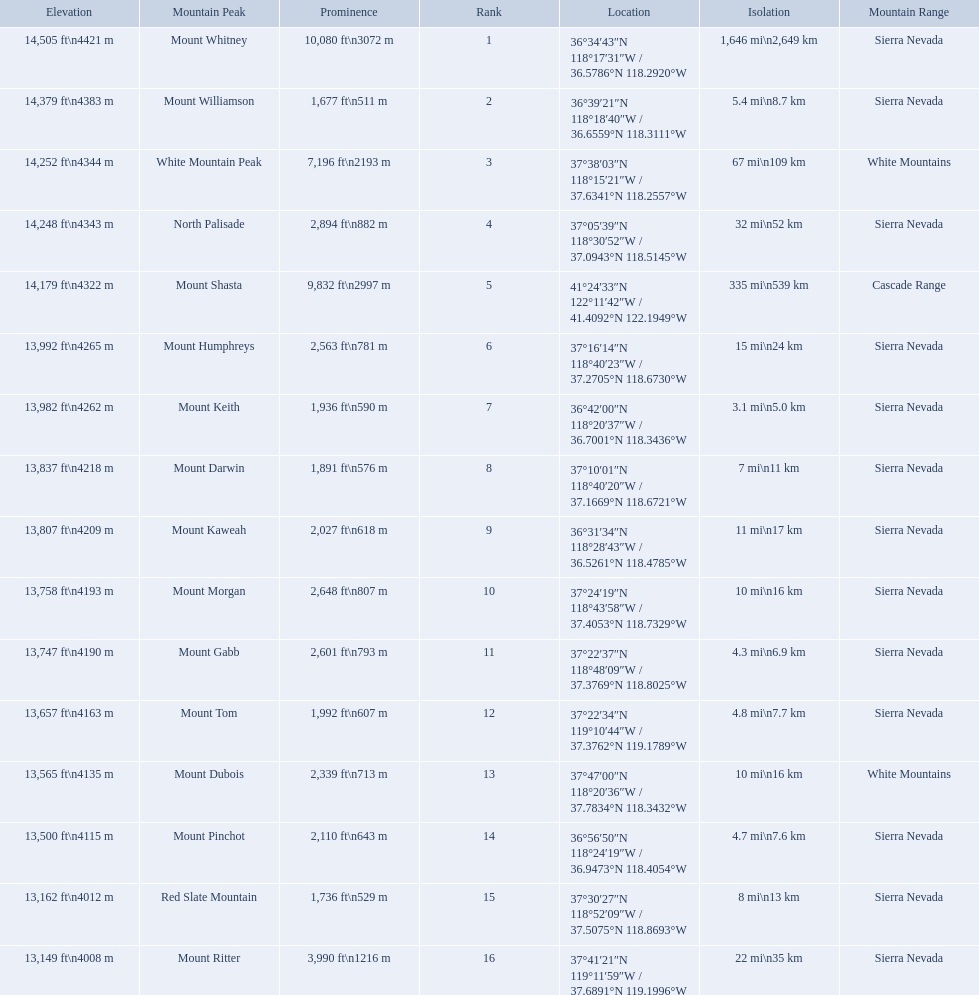Parse the full table in json format. {'header': ['Elevation', 'Mountain Peak', 'Prominence', 'Rank', 'Location', 'Isolation', 'Mountain Range'], 'rows': [['14,505\xa0ft\\n4421\xa0m', 'Mount Whitney', '10,080\xa0ft\\n3072\xa0m', '1', '36°34′43″N 118°17′31″W\ufeff / \ufeff36.5786°N 118.2920°W', '1,646\xa0mi\\n2,649\xa0km', 'Sierra Nevada'], ['14,379\xa0ft\\n4383\xa0m', 'Mount Williamson', '1,677\xa0ft\\n511\xa0m', '2', '36°39′21″N 118°18′40″W\ufeff / \ufeff36.6559°N 118.3111°W', '5.4\xa0mi\\n8.7\xa0km', 'Sierra Nevada'], ['14,252\xa0ft\\n4344\xa0m', 'White Mountain Peak', '7,196\xa0ft\\n2193\xa0m', '3', '37°38′03″N 118°15′21″W\ufeff / \ufeff37.6341°N 118.2557°W', '67\xa0mi\\n109\xa0km', 'White Mountains'], ['14,248\xa0ft\\n4343\xa0m', 'North Palisade', '2,894\xa0ft\\n882\xa0m', '4', '37°05′39″N 118°30′52″W\ufeff / \ufeff37.0943°N 118.5145°W', '32\xa0mi\\n52\xa0km', 'Sierra Nevada'], ['14,179\xa0ft\\n4322\xa0m', 'Mount Shasta', '9,832\xa0ft\\n2997\xa0m', '5', '41°24′33″N 122°11′42″W\ufeff / \ufeff41.4092°N 122.1949°W', '335\xa0mi\\n539\xa0km', 'Cascade Range'], ['13,992\xa0ft\\n4265\xa0m', 'Mount Humphreys', '2,563\xa0ft\\n781\xa0m', '6', '37°16′14″N 118°40′23″W\ufeff / \ufeff37.2705°N 118.6730°W', '15\xa0mi\\n24\xa0km', 'Sierra Nevada'], ['13,982\xa0ft\\n4262\xa0m', 'Mount Keith', '1,936\xa0ft\\n590\xa0m', '7', '36°42′00″N 118°20′37″W\ufeff / \ufeff36.7001°N 118.3436°W', '3.1\xa0mi\\n5.0\xa0km', 'Sierra Nevada'], ['13,837\xa0ft\\n4218\xa0m', 'Mount Darwin', '1,891\xa0ft\\n576\xa0m', '8', '37°10′01″N 118°40′20″W\ufeff / \ufeff37.1669°N 118.6721°W', '7\xa0mi\\n11\xa0km', 'Sierra Nevada'], ['13,807\xa0ft\\n4209\xa0m', 'Mount Kaweah', '2,027\xa0ft\\n618\xa0m', '9', '36°31′34″N 118°28′43″W\ufeff / \ufeff36.5261°N 118.4785°W', '11\xa0mi\\n17\xa0km', 'Sierra Nevada'], ['13,758\xa0ft\\n4193\xa0m', 'Mount Morgan', '2,648\xa0ft\\n807\xa0m', '10', '37°24′19″N 118°43′58″W\ufeff / \ufeff37.4053°N 118.7329°W', '10\xa0mi\\n16\xa0km', 'Sierra Nevada'], ['13,747\xa0ft\\n4190\xa0m', 'Mount Gabb', '2,601\xa0ft\\n793\xa0m', '11', '37°22′37″N 118°48′09″W\ufeff / \ufeff37.3769°N 118.8025°W', '4.3\xa0mi\\n6.9\xa0km', 'Sierra Nevada'], ['13,657\xa0ft\\n4163\xa0m', 'Mount Tom', '1,992\xa0ft\\n607\xa0m', '12', '37°22′34″N 119°10′44″W\ufeff / \ufeff37.3762°N 119.1789°W', '4.8\xa0mi\\n7.7\xa0km', 'Sierra Nevada'], ['13,565\xa0ft\\n4135\xa0m', 'Mount Dubois', '2,339\xa0ft\\n713\xa0m', '13', '37°47′00″N 118°20′36″W\ufeff / \ufeff37.7834°N 118.3432°W', '10\xa0mi\\n16\xa0km', 'White Mountains'], ['13,500\xa0ft\\n4115\xa0m', 'Mount Pinchot', '2,110\xa0ft\\n643\xa0m', '14', '36°56′50″N 118°24′19″W\ufeff / \ufeff36.9473°N 118.4054°W', '4.7\xa0mi\\n7.6\xa0km', 'Sierra Nevada'], ['13,162\xa0ft\\n4012\xa0m', 'Red Slate Mountain', '1,736\xa0ft\\n529\xa0m', '15', '37°30′27″N 118°52′09″W\ufeff / \ufeff37.5075°N 118.8693°W', '8\xa0mi\\n13\xa0km', 'Sierra Nevada'], ['13,149\xa0ft\\n4008\xa0m', 'Mount Ritter', '3,990\xa0ft\\n1216\xa0m', '16', '37°41′21″N 119°11′59″W\ufeff / \ufeff37.6891°N 119.1996°W', '22\xa0mi\\n35\xa0km', 'Sierra Nevada']]} What mountain peak is listed for the sierra nevada mountain range? Mount Whitney. What mountain peak has an elevation of 14,379ft? Mount Williamson. Which mountain is listed for the cascade range? Mount Shasta. 